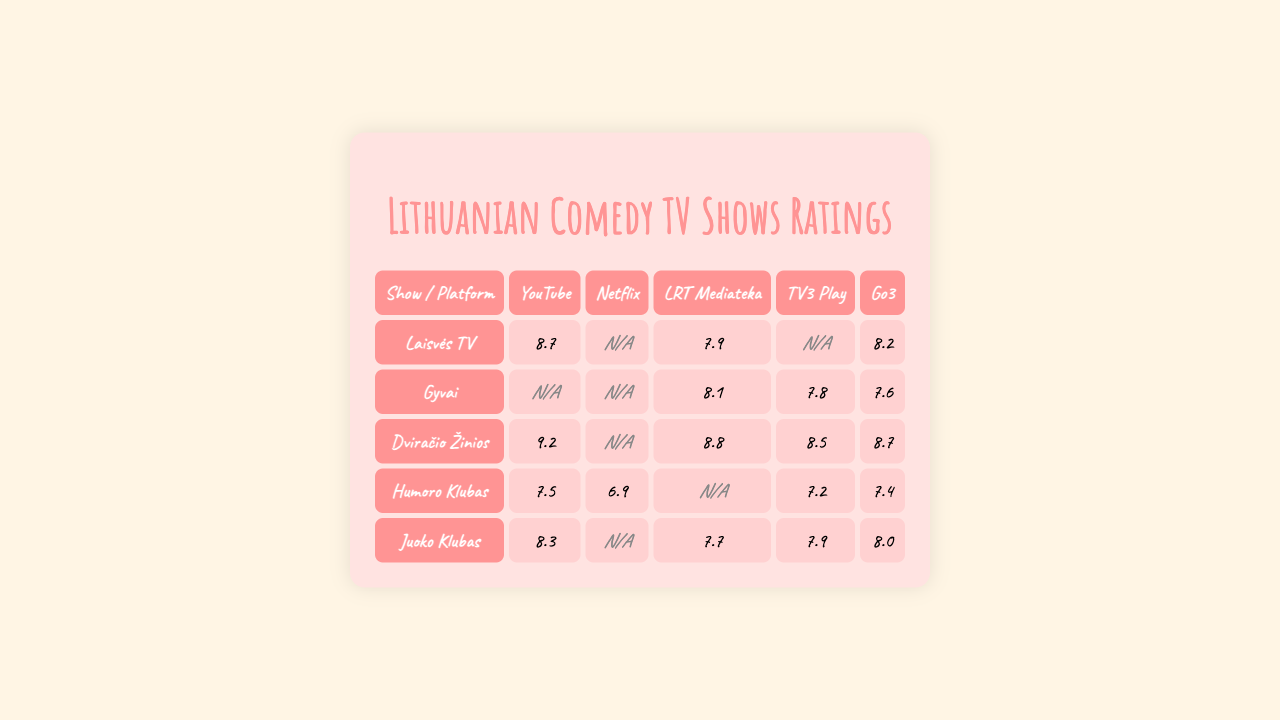What is the highest rating for "Laisvės TV" on any platform? The ratings for "Laisvės TV" are: 8.7 (YouTube), 0 (Netflix), 7.9 (LRT Mediateka), 0 (TV3 Play), 8.2 (Go3). The highest rating is 8.7 on YouTube.
Answer: 8.7 Which platform has the lowest rating for "Gyvai"? The ratings for "Gyvai" are: 0 (YouTube), 0 (Netflix), 8.1 (LRT Mediateka), 7.8 (TV3 Play), 7.6 (Go3). The lowest rating is 0 on both YouTube and Netflix.
Answer: 0 What is the average rating of "Dviračio Žinios" across all platforms? The ratings for "Dviračio Žinios" are: 9.2 (YouTube), 0 (Netflix), 8.8 (LRT Mediateka), 8.5 (TV3 Play), 8.7 (Go3). First, sum the ratings excluding 0: 9.2 + 8.8 + 8.5 + 8.7 = 35.2. There are 4 ratings to average: 35.2 / 4 = 8.8.
Answer: 8.8 Is "Humoro Klubas" available on Netflix? The rating for "Humoro Klubas" on Netflix is 6.9, which means it has a rating available.
Answer: Yes Which show performs best on Go3? The ratings on Go3 are: "Laisvės TV" (8.2), "Gyvai" (7.6), "Dviračio Žinios" (8.7), "Humoro Klubas" (7.4), "Juoko Klubas" (8.0). The highest is 8.7 for "Dviračio Žinios".
Answer: Dviračio Žinios What is the total number of shows that have a rating on LRT Mediateka? The ratings on LRT Mediateka are: "Laisvės TV" (0), "Gyvai" (8.1), "Dviračio Žinios" (8.8), "Humoro Klubas" (0), "Juoko Klubas" (7.7). Only "Gyvai," "Dviračio Žinios," and "Juoko Klubas" have ratings. There are 3 shows with ratings.
Answer: 3 What is the difference in average ratings between "Juoko Klubas" and "Humoro Klubas"? "Juoko Klubas" ratings are: 8.3 (YouTube), 0 (Netflix), 7.7 (LRT Mediateka), 7.9 (TV3 Play), 8.0 (Go3). Average = (8.3 + 7.7 + 7.9 + 8.0) / 4 = 8.05. "Humoro Klubas" ratings are: 7.5 (YouTube), 6.9 (Netflix), 0 (LRT Mediateka), 7.2 (TV3 Play), 7.4 (Go3). Average = (7.5 + 6.9 + 7.2 + 7.4) / 4 = 7.5. The difference is 8.05 - 7.5 = 0.55.
Answer: 0.55 Which show has the highest rating on YouTube? The ratings on YouTube are: "Laisvės TV" (8.7), "Gyvai" (0), "Dviračio Žinios" (9.2), "Humoro Klubas" (7.5), "Juoko Klubas" (8.3). The highest rating is 9.2 for "Dviračio Žinios".
Answer: Dviračio Žinios Are there any shows with a rating of 0 on TV3 Play? The ratings on TV3 Play are: "Laisvės TV" (0), "Gyvai" (7.8), "Dviračio Žinios" (8.5), "Humoro Klubas" (7.2), "Juoko Klubas" (7.9). "Laisvės TV" has a rating of 0.
Answer: Yes What is the median rating for "Juoko Klubas"? The ratings for "Juoko Klubas" are: 8.3 (YouTube), 0 (Netflix), 7.7 (LRT Mediateka), 7.9 (TV3 Play), 8.0 (Go3). First, we sort the ratings excluding 0: [7.7, 7.9, 8.0, 8.3]. There are 4 ratings: the median is the average of the 2 middle numbers (7.9 and 8.0), which is (7.9 + 8.0) / 2 = 7.95.
Answer: 7.95 